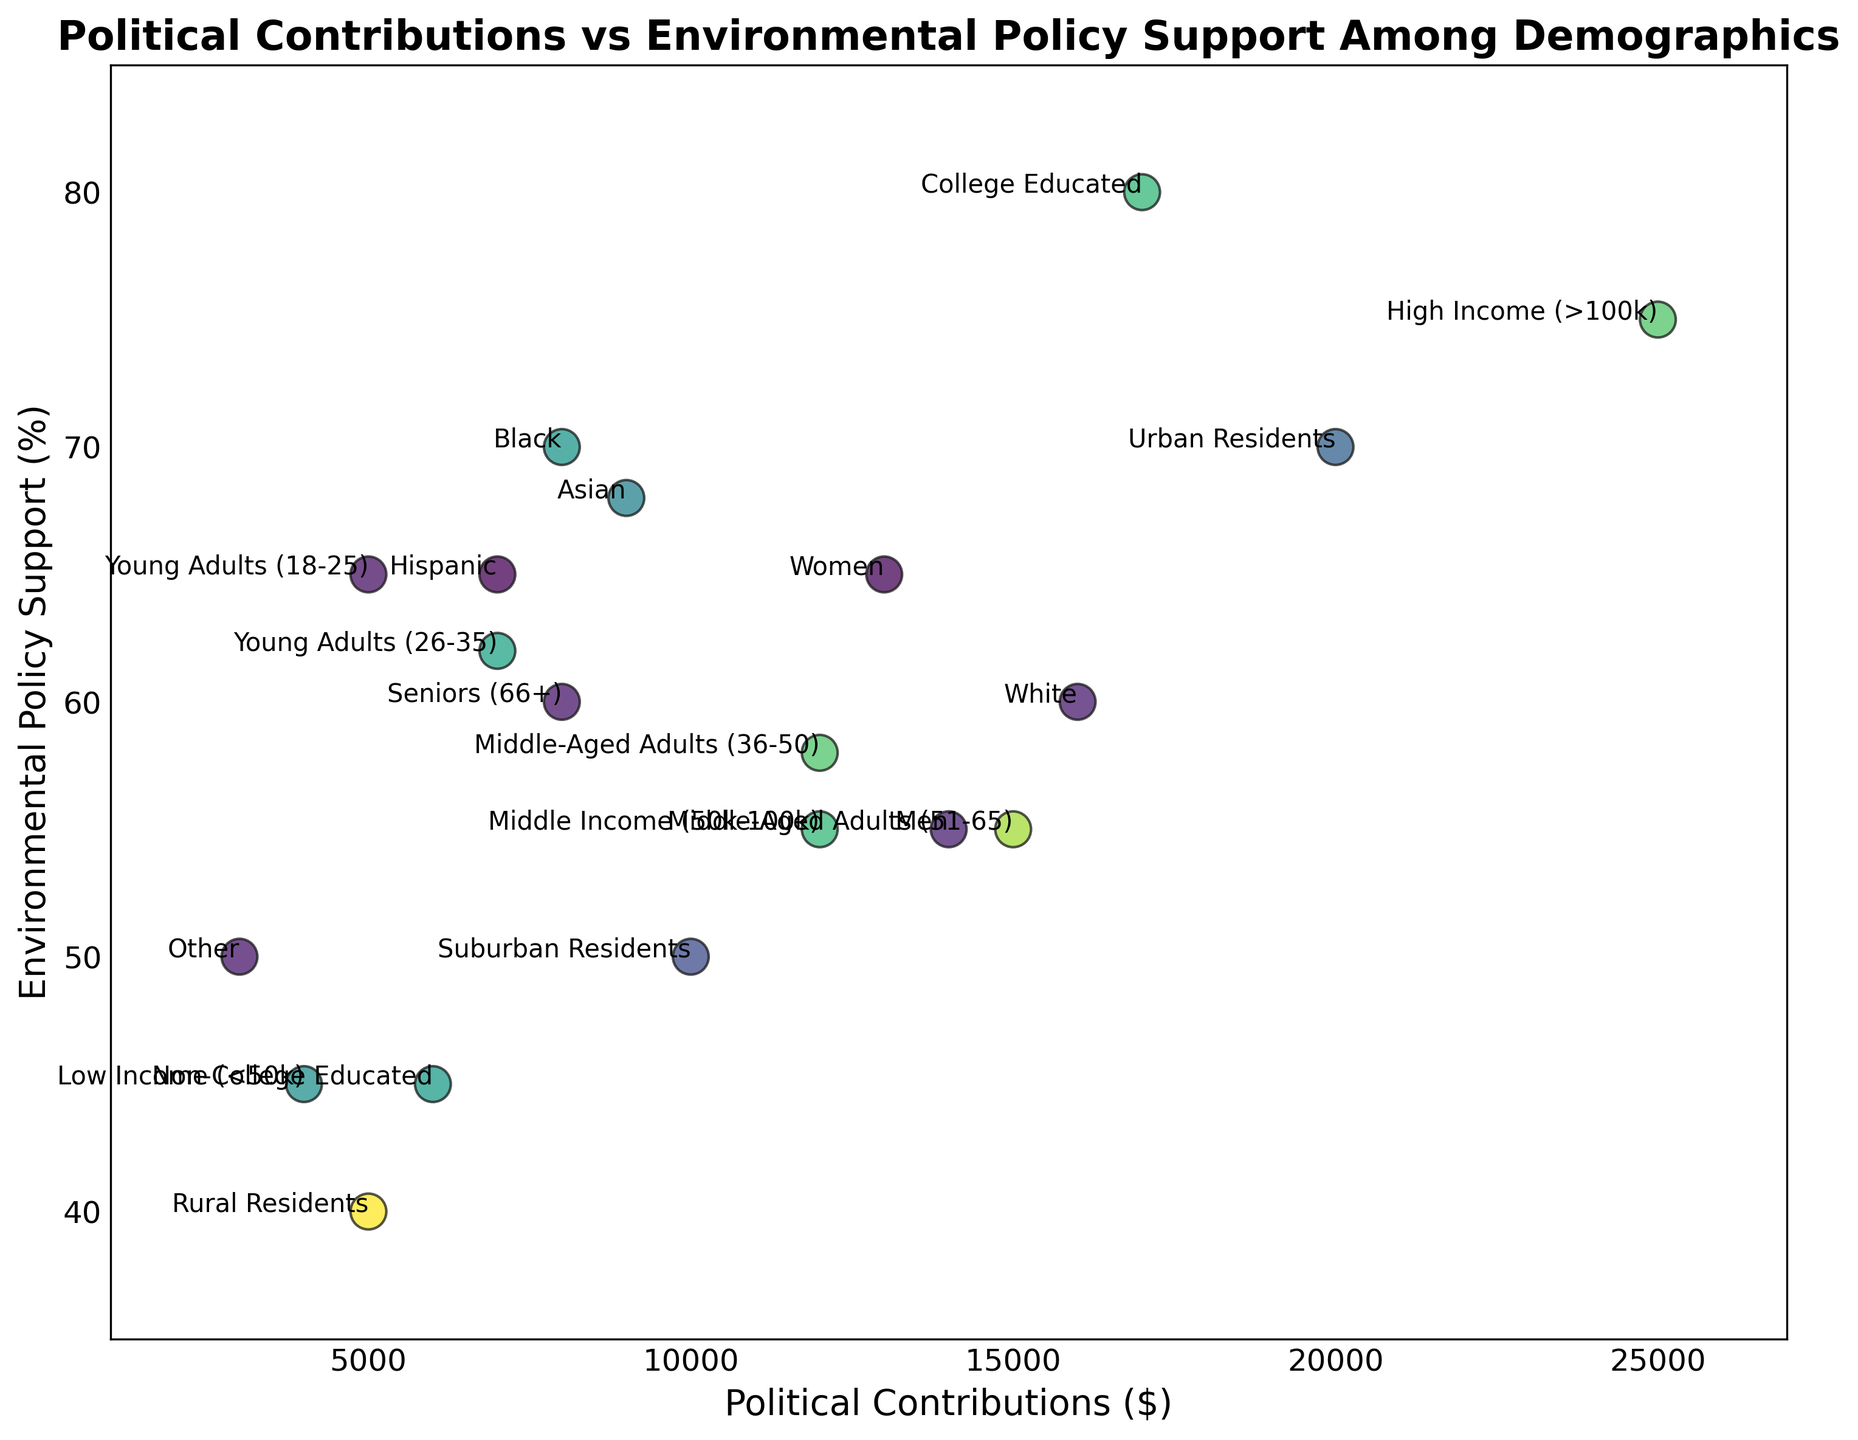What demographic group has the lowest environmental policy support and what percentage is it? By looking at the scatter points and identifying the annotations, we can see that Rural Residents have the lowest environmental policy support percentage.
Answer: 40% Which demographic group makes the highest political contributions and what is the amount? By looking at the scatter points and identifying the annotations, we can see that High Income (>100k) makes the highest political contributions.
Answer: $25000 What is the difference in political contributions between Urban Residents and Rural Residents? Urban Residents give $20,000 in political contributions, and Rural Residents give $5,000. Therefore, the difference is $20,000 - $5,000.
Answer: $15,000 Which demographic group has the highest environmental policy support percentage? From the scatter points, College Educated has the highest environmental policy support percentage.
Answer: 80% How much do Middle-Aged Adults (36-50) contribute compared to Middle-Aged Adults (51-65) and who contributes more? Middle-Aged Adults (36-50) contribute $12,000, and Middle-Aged Adults (51-65) contribute $15,000. Comparing these values, Middle-Aged Adults (51-65) contribute more.
Answer: Middle-Aged Adults (51-65), $15,000 Which demographic groups have an environmental policy support percentage of 65%? By locating the scatter points with 65% environmental policy support and checking the annotations, the groups are Young Adults (18-25), Hispanic, and Women.
Answer: Young Adults (18-25), Hispanic, Women How does the environmental policy support percentage of College Educated compare to Non-College Educated? College Educated has an environmental policy support percentage of 80%, while Non-College Educated has 45%. Comparing these values shows that College Educated has a substantially higher support percentage.
Answer: College Educated, 80%; Non-College Educated, 45% What is the average political contribution of Men and Women combined? Adding up the political contributions of Men ($14,000) and Women ($13,000), we get $27,000. Dividing by 2 gives the average.
Answer: $13,500 Which group supports environmental policies more, Urban Residents or Suburban Residents? From the scatter points, Urban Residents have a support percentage of 70%, whereas Suburban Residents have 50%. Urban Residents have higher support.
Answer: Urban Residents, 70% What is the sum of political contributions of Young Adults (18-25) and Young Adults (26-35)? The political contributions of Young Adults (18-25) is $5,000 and Young Adults (26-35) is $7,000. The sum is $5,000 + $7,000.
Answer: $12,000 